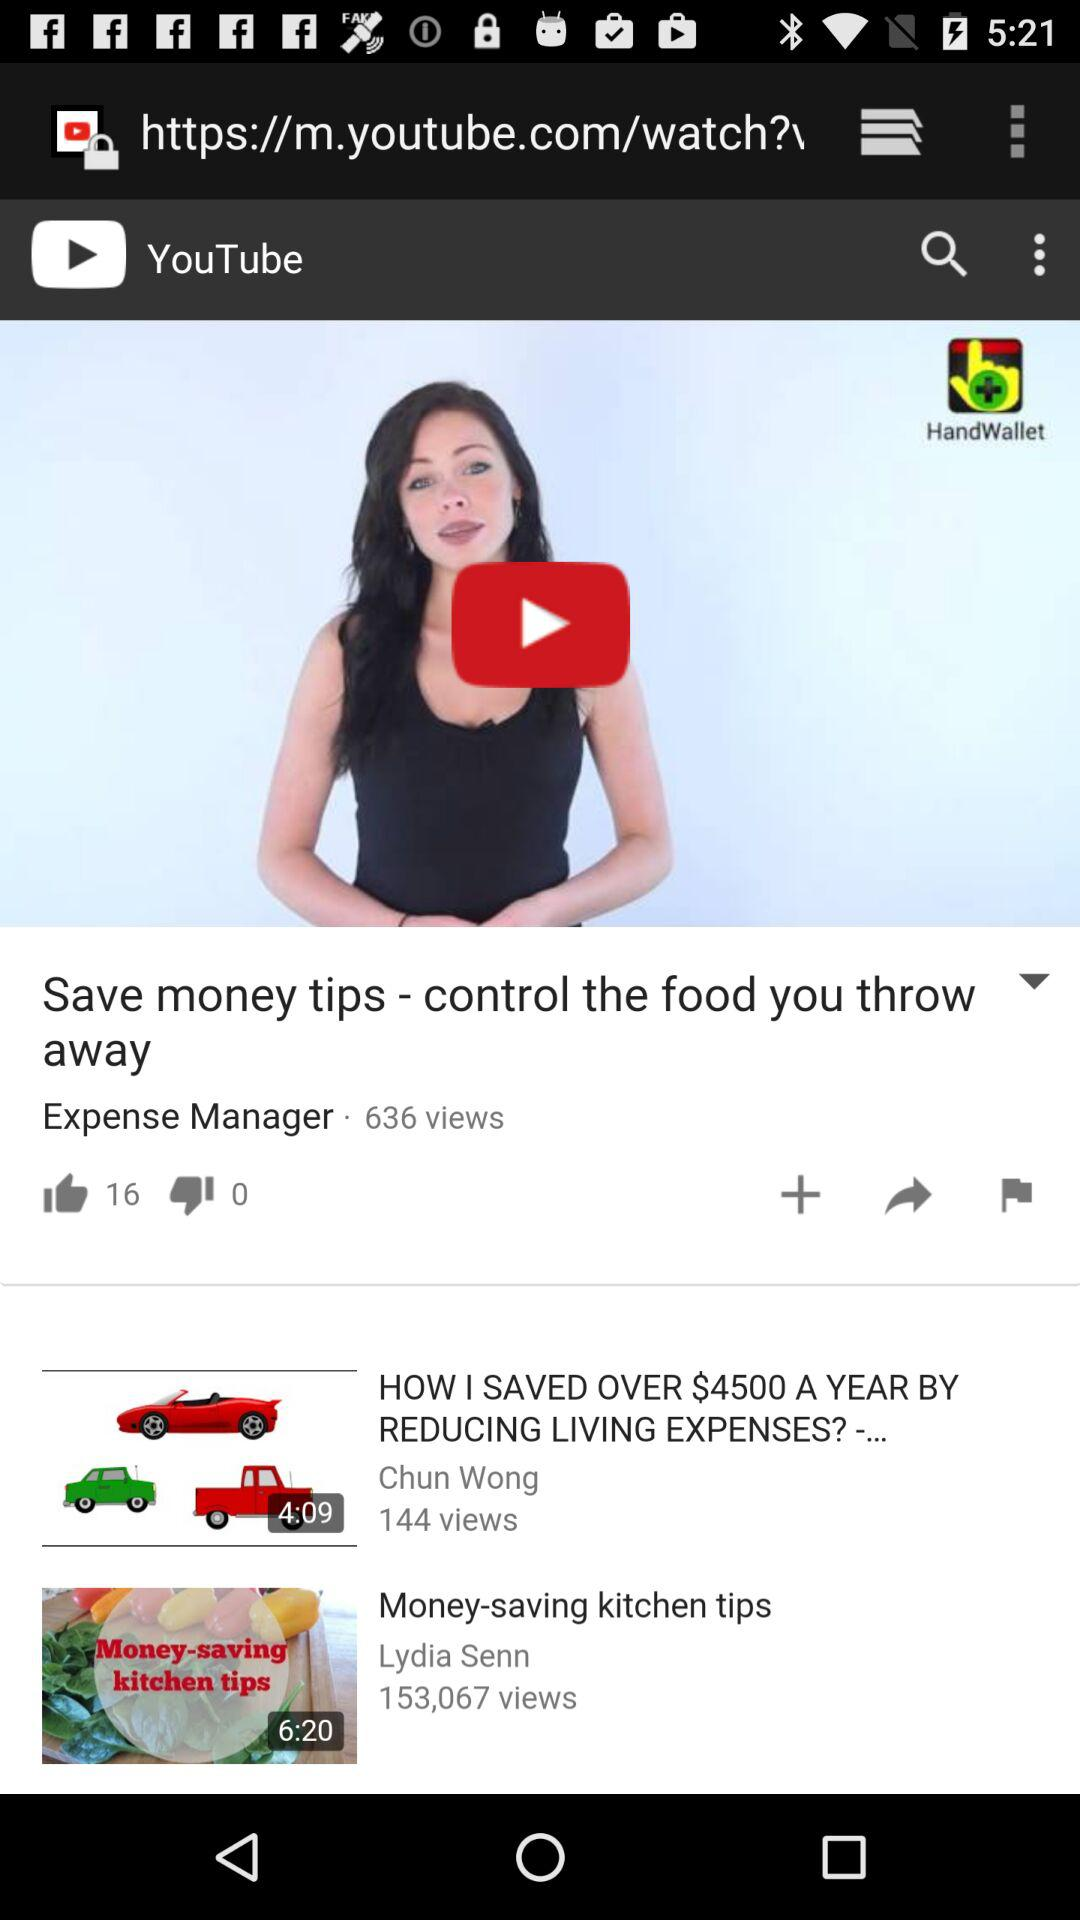How many more thumbs up does the video with the title 'Expense Manager' have than the video with the title 'How I Saved Over $4500 A Year By Reducing Living Expenses? -...'?
Answer the question using a single word or phrase. 16 